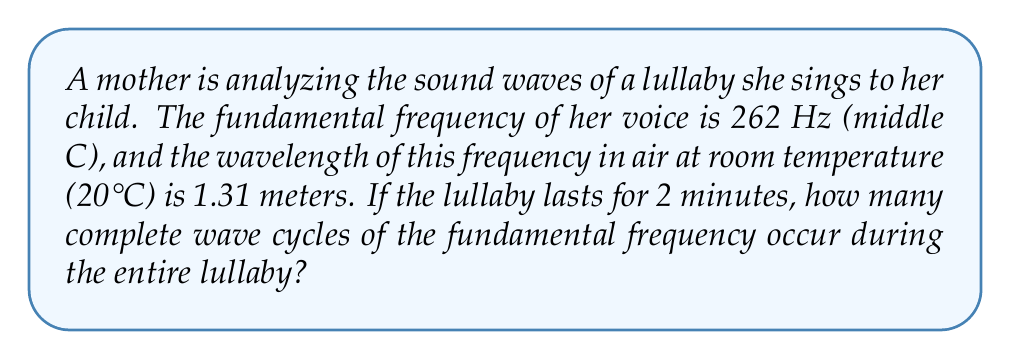Could you help me with this problem? Let's approach this step-by-step:

1) First, we need to understand what the question is asking. We're looking for the number of complete wave cycles during the entire lullaby.

2) We're given the fundamental frequency (f) and the duration (t) of the lullaby:
   f = 262 Hz
   t = 2 minutes = 120 seconds

3) The number of cycles (N) is equal to the frequency multiplied by the time:

   $$ N = f \times t $$

4) Let's substitute our values:

   $$ N = 262 \text{ Hz} \times 120 \text{ s} $$

5) Recall that Hz is cycles per second, so Hz * s = cycles

6) Calculate:

   $$ N = 31,440 \text{ cycles} $$

Note: The wavelength information wasn't necessary for this calculation, but it's included to provide context about the physical properties of the sound wave, which might be interesting for a mom analyzing lullabies.
Answer: 31,440 cycles 